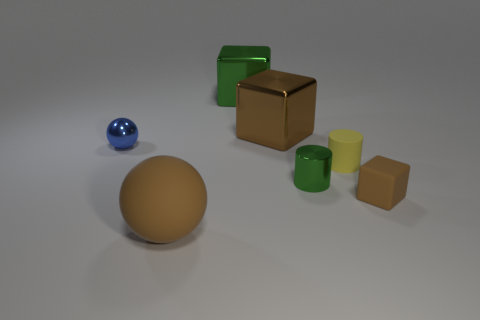There is a ball in front of the tiny rubber cube; does it have the same color as the object on the right side of the yellow thing?
Make the answer very short. Yes. There is a big object that is the same color as the rubber ball; what material is it?
Give a very brief answer. Metal. The small metal sphere has what color?
Offer a very short reply. Blue. The small matte thing to the right of the yellow rubber object that is in front of the blue thing is what color?
Give a very brief answer. Brown. There is a green metallic thing that is behind the shiny thing that is in front of the metallic thing to the left of the large brown rubber thing; what is its shape?
Ensure brevity in your answer.  Cube. How many green objects have the same material as the tiny ball?
Offer a very short reply. 2. How many big objects are in front of the green object left of the metal cylinder?
Provide a short and direct response. 2. How many large green metal objects are there?
Offer a terse response. 1. Is the material of the big green block the same as the brown object behind the tiny green object?
Ensure brevity in your answer.  Yes. There is a cube that is in front of the tiny green metallic thing; does it have the same color as the tiny rubber cylinder?
Make the answer very short. No. 